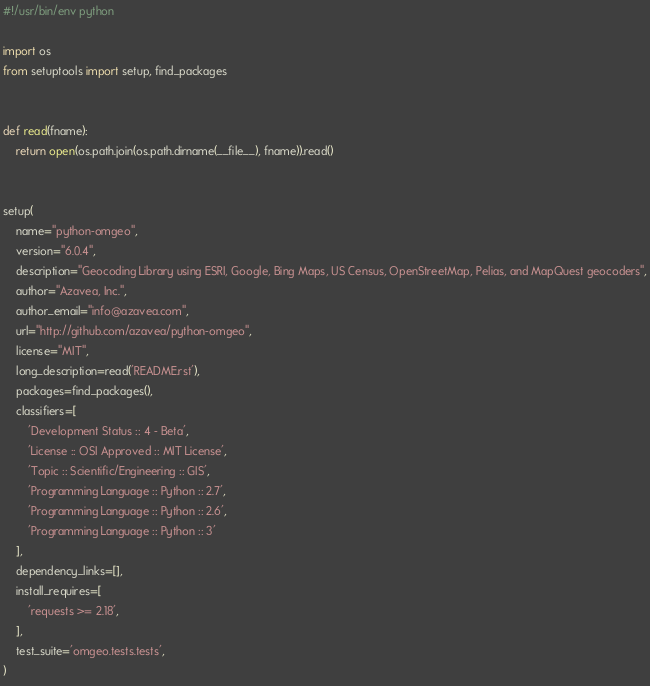Convert code to text. <code><loc_0><loc_0><loc_500><loc_500><_Python_>#!/usr/bin/env python

import os
from setuptools import setup, find_packages


def read(fname):
    return open(os.path.join(os.path.dirname(__file__), fname)).read()


setup(
    name="python-omgeo",
    version="6.0.4",
    description="Geocoding Library using ESRI, Google, Bing Maps, US Census, OpenStreetMap, Pelias, and MapQuest geocoders",
    author="Azavea, Inc.",
    author_email="info@azavea.com",
    url="http://github.com/azavea/python-omgeo",
    license="MIT",
    long_description=read('README.rst'),
    packages=find_packages(),
    classifiers=[
        'Development Status :: 4 - Beta',
        'License :: OSI Approved :: MIT License',
        'Topic :: Scientific/Engineering :: GIS',
        'Programming Language :: Python :: 2.7',
        'Programming Language :: Python :: 2.6',
        'Programming Language :: Python :: 3'
    ],
    dependency_links=[],
    install_requires=[
        'requests >= 2.18',
    ],
    test_suite='omgeo.tests.tests',
)
</code> 